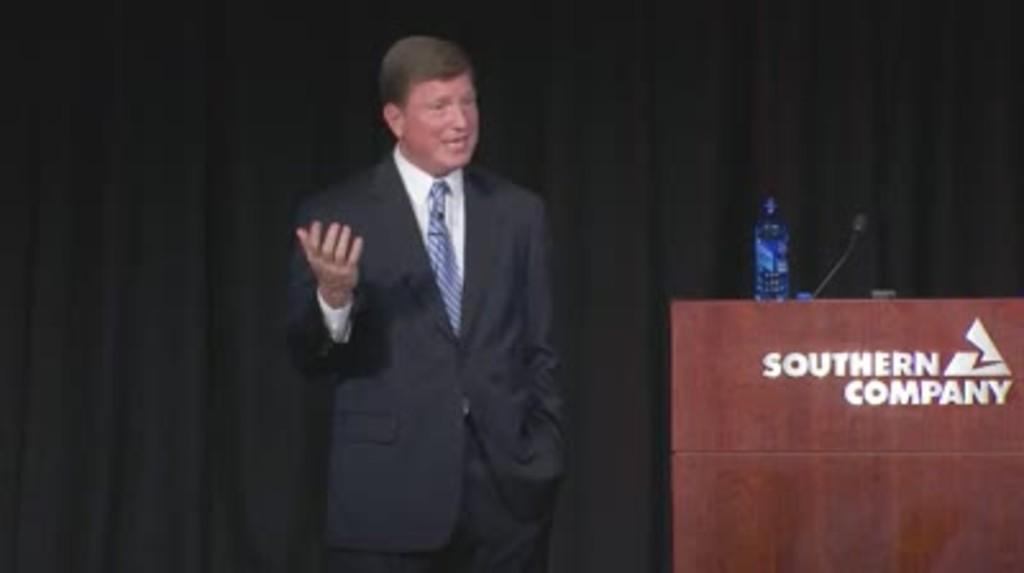Can you describe this image briefly? The person wearing black suit is standing and there is a wooden stand beside him which has a mic and water bottle placed on it. 